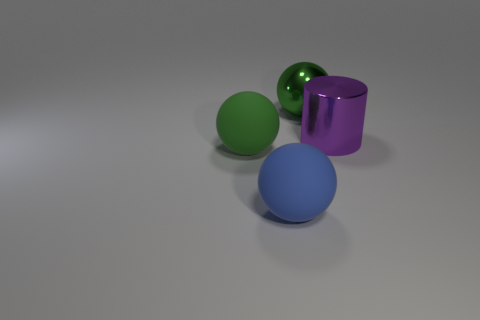How many green spheres must be subtracted to get 1 green spheres? 1 Subtract all green matte spheres. How many spheres are left? 2 Subtract all gray cylinders. How many green balls are left? 2 Add 4 blue things. How many objects exist? 8 Subtract all brown balls. Subtract all cyan cylinders. How many balls are left? 3 Subtract 0 cyan cylinders. How many objects are left? 4 Subtract all cylinders. How many objects are left? 3 Subtract all blue metallic balls. Subtract all big green metallic objects. How many objects are left? 3 Add 4 big things. How many big things are left? 8 Add 2 spheres. How many spheres exist? 5 